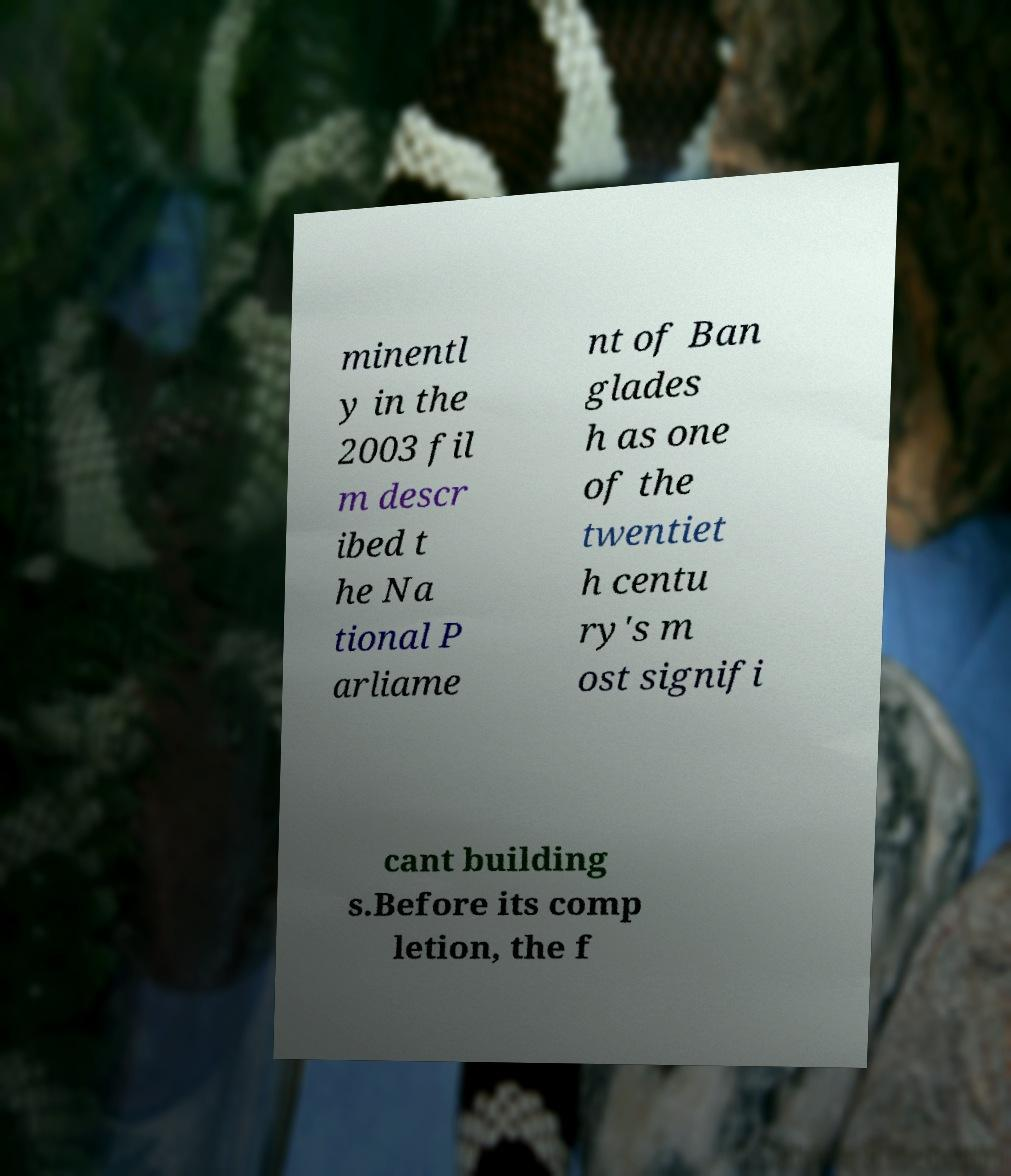Can you accurately transcribe the text from the provided image for me? minentl y in the 2003 fil m descr ibed t he Na tional P arliame nt of Ban glades h as one of the twentiet h centu ry's m ost signifi cant building s.Before its comp letion, the f 